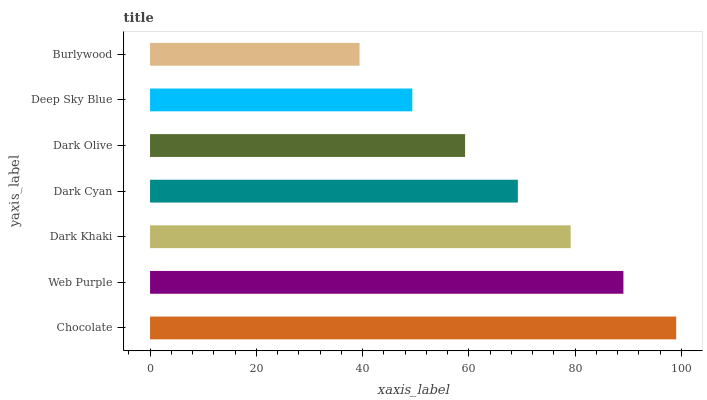Is Burlywood the minimum?
Answer yes or no. Yes. Is Chocolate the maximum?
Answer yes or no. Yes. Is Web Purple the minimum?
Answer yes or no. No. Is Web Purple the maximum?
Answer yes or no. No. Is Chocolate greater than Web Purple?
Answer yes or no. Yes. Is Web Purple less than Chocolate?
Answer yes or no. Yes. Is Web Purple greater than Chocolate?
Answer yes or no. No. Is Chocolate less than Web Purple?
Answer yes or no. No. Is Dark Cyan the high median?
Answer yes or no. Yes. Is Dark Cyan the low median?
Answer yes or no. Yes. Is Burlywood the high median?
Answer yes or no. No. Is Deep Sky Blue the low median?
Answer yes or no. No. 